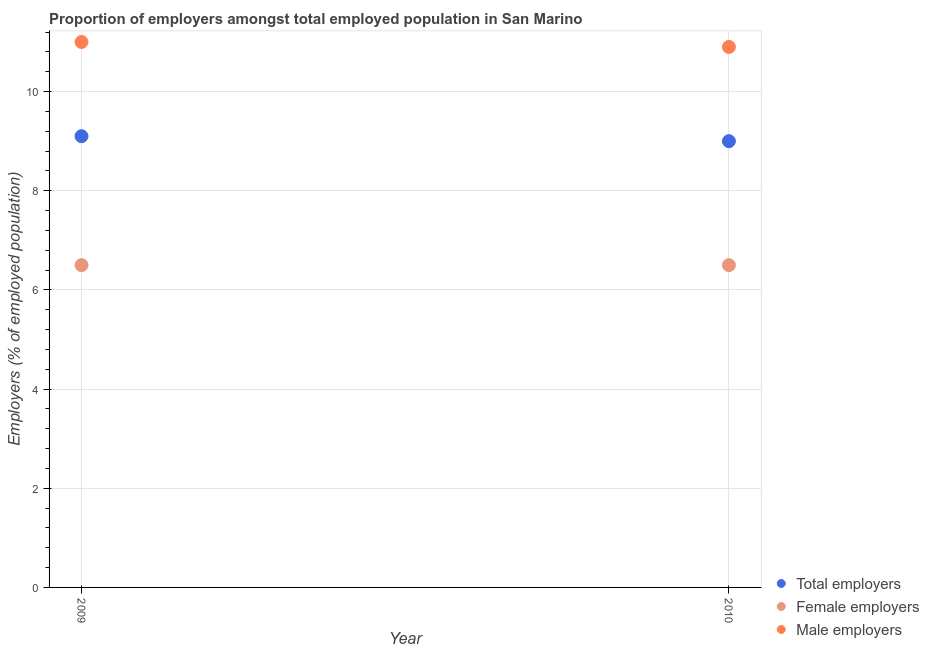Is the number of dotlines equal to the number of legend labels?
Offer a very short reply. Yes. What is the percentage of female employers in 2010?
Your answer should be compact. 6.5. In which year was the percentage of male employers maximum?
Keep it short and to the point. 2009. What is the total percentage of male employers in the graph?
Make the answer very short. 21.9. What is the difference between the percentage of male employers in 2009 and that in 2010?
Provide a short and direct response. 0.1. What is the difference between the percentage of female employers in 2010 and the percentage of total employers in 2009?
Provide a short and direct response. -2.6. In the year 2010, what is the difference between the percentage of female employers and percentage of male employers?
Your response must be concise. -4.4. In how many years, is the percentage of male employers greater than 6.4 %?
Your response must be concise. 2. What is the ratio of the percentage of female employers in 2009 to that in 2010?
Keep it short and to the point. 1. Is the percentage of total employers in 2009 less than that in 2010?
Offer a very short reply. No. In how many years, is the percentage of total employers greater than the average percentage of total employers taken over all years?
Offer a very short reply. 1. Is it the case that in every year, the sum of the percentage of total employers and percentage of female employers is greater than the percentage of male employers?
Give a very brief answer. Yes. Does the percentage of total employers monotonically increase over the years?
Your answer should be compact. No. Is the percentage of total employers strictly greater than the percentage of female employers over the years?
Provide a short and direct response. Yes. Is the percentage of male employers strictly less than the percentage of total employers over the years?
Your answer should be very brief. No. Does the graph contain any zero values?
Offer a very short reply. No. Where does the legend appear in the graph?
Provide a succinct answer. Bottom right. How many legend labels are there?
Provide a succinct answer. 3. How are the legend labels stacked?
Offer a terse response. Vertical. What is the title of the graph?
Your response must be concise. Proportion of employers amongst total employed population in San Marino. What is the label or title of the Y-axis?
Offer a very short reply. Employers (% of employed population). What is the Employers (% of employed population) of Total employers in 2009?
Provide a succinct answer. 9.1. What is the Employers (% of employed population) in Female employers in 2009?
Keep it short and to the point. 6.5. What is the Employers (% of employed population) in Male employers in 2009?
Offer a very short reply. 11. What is the Employers (% of employed population) in Female employers in 2010?
Offer a terse response. 6.5. What is the Employers (% of employed population) in Male employers in 2010?
Your answer should be compact. 10.9. Across all years, what is the maximum Employers (% of employed population) in Total employers?
Make the answer very short. 9.1. Across all years, what is the minimum Employers (% of employed population) in Male employers?
Provide a succinct answer. 10.9. What is the total Employers (% of employed population) of Female employers in the graph?
Your answer should be compact. 13. What is the total Employers (% of employed population) of Male employers in the graph?
Offer a very short reply. 21.9. What is the difference between the Employers (% of employed population) in Female employers in 2009 and that in 2010?
Your response must be concise. 0. What is the difference between the Employers (% of employed population) in Male employers in 2009 and that in 2010?
Keep it short and to the point. 0.1. What is the difference between the Employers (% of employed population) of Total employers in 2009 and the Employers (% of employed population) of Male employers in 2010?
Provide a short and direct response. -1.8. What is the average Employers (% of employed population) in Total employers per year?
Keep it short and to the point. 9.05. What is the average Employers (% of employed population) in Male employers per year?
Your answer should be very brief. 10.95. In the year 2009, what is the difference between the Employers (% of employed population) in Total employers and Employers (% of employed population) in Female employers?
Ensure brevity in your answer.  2.6. In the year 2010, what is the difference between the Employers (% of employed population) in Total employers and Employers (% of employed population) in Male employers?
Give a very brief answer. -1.9. What is the ratio of the Employers (% of employed population) of Total employers in 2009 to that in 2010?
Provide a succinct answer. 1.01. What is the ratio of the Employers (% of employed population) in Female employers in 2009 to that in 2010?
Your response must be concise. 1. What is the ratio of the Employers (% of employed population) of Male employers in 2009 to that in 2010?
Offer a terse response. 1.01. What is the difference between the highest and the second highest Employers (% of employed population) in Total employers?
Your answer should be compact. 0.1. What is the difference between the highest and the lowest Employers (% of employed population) of Total employers?
Give a very brief answer. 0.1. What is the difference between the highest and the lowest Employers (% of employed population) of Female employers?
Give a very brief answer. 0. 